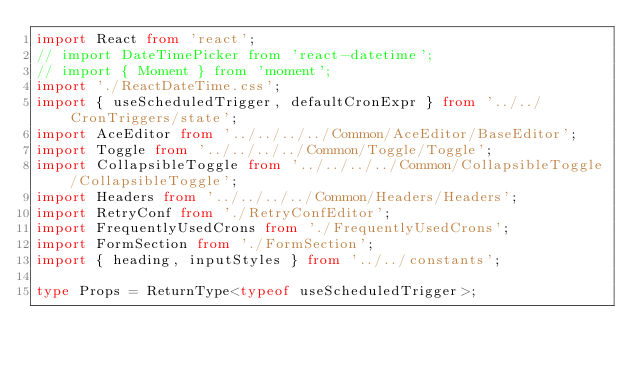Convert code to text. <code><loc_0><loc_0><loc_500><loc_500><_TypeScript_>import React from 'react';
// import DateTimePicker from 'react-datetime';
// import { Moment } from 'moment';
import './ReactDateTime.css';
import { useScheduledTrigger, defaultCronExpr } from '../../CronTriggers/state';
import AceEditor from '../../../../Common/AceEditor/BaseEditor';
import Toggle from '../../../../Common/Toggle/Toggle';
import CollapsibleToggle from '../../../../Common/CollapsibleToggle/CollapsibleToggle';
import Headers from '../../../../Common/Headers/Headers';
import RetryConf from './RetryConfEditor';
import FrequentlyUsedCrons from './FrequentlyUsedCrons';
import FormSection from './FormSection';
import { heading, inputStyles } from '../../constants';

type Props = ReturnType<typeof useScheduledTrigger>;
</code> 